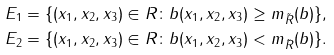<formula> <loc_0><loc_0><loc_500><loc_500>E _ { 1 } & = \{ ( x _ { 1 } , x _ { 2 } , x _ { 3 } ) \in R \colon b ( x _ { 1 } , x _ { 2 } , x _ { 3 } ) \geq m _ { \tilde { R } } ( b ) \} , \\ E _ { 2 } & = \{ ( x _ { 1 } , x _ { 2 } , x _ { 3 } ) \in R \colon b ( x _ { 1 } , x _ { 2 } , x _ { 3 } ) < m _ { \tilde { R } } ( b ) \} .</formula> 